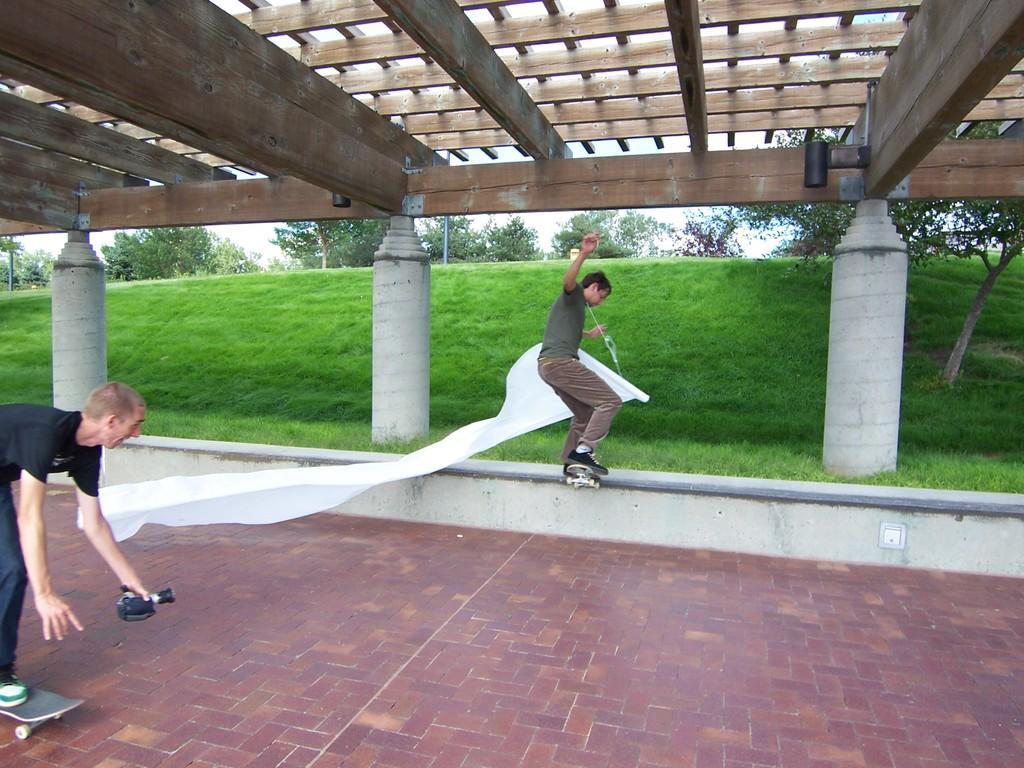Could you give a brief overview of what you see in this image? In this image I can see the ground and two persons are skateboarding. I can see a person is holding a camera and another person is holding a white colored cloth. In the background I can see few pillars, some grass, few trees and the sky. 